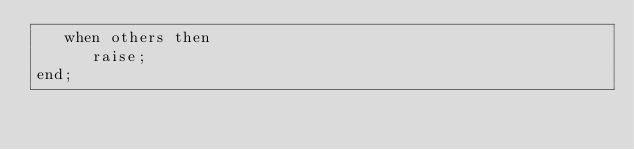Convert code to text. <code><loc_0><loc_0><loc_500><loc_500><_SQL_>   when others then
      raise;
end;
</code> 